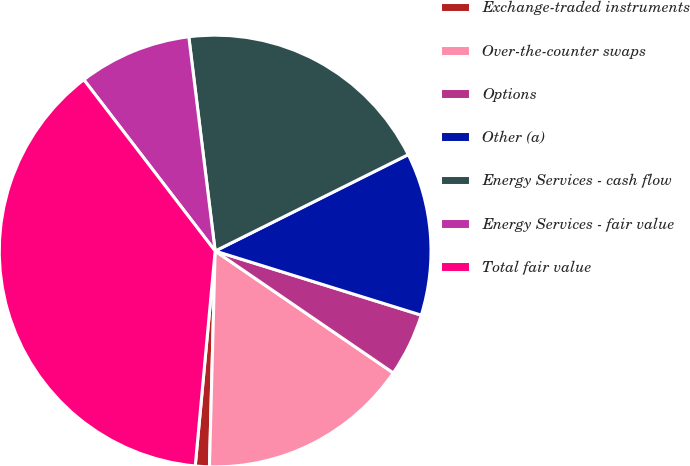<chart> <loc_0><loc_0><loc_500><loc_500><pie_chart><fcel>Exchange-traded instruments<fcel>Over-the-counter swaps<fcel>Options<fcel>Other (a)<fcel>Energy Services - cash flow<fcel>Energy Services - fair value<fcel>Total fair value<nl><fcel>1.05%<fcel>15.87%<fcel>4.75%<fcel>12.17%<fcel>19.58%<fcel>8.46%<fcel>38.12%<nl></chart> 